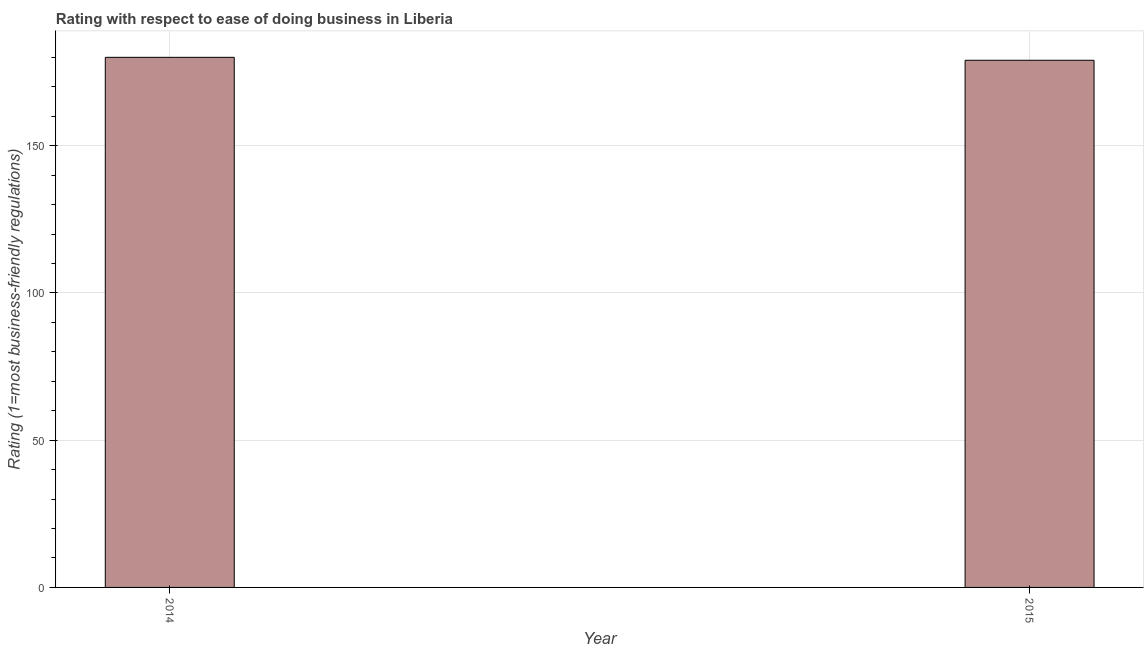What is the title of the graph?
Your answer should be compact. Rating with respect to ease of doing business in Liberia. What is the label or title of the Y-axis?
Ensure brevity in your answer.  Rating (1=most business-friendly regulations). What is the ease of doing business index in 2014?
Your answer should be compact. 180. Across all years, what is the maximum ease of doing business index?
Ensure brevity in your answer.  180. Across all years, what is the minimum ease of doing business index?
Ensure brevity in your answer.  179. In which year was the ease of doing business index minimum?
Your answer should be very brief. 2015. What is the sum of the ease of doing business index?
Offer a terse response. 359. What is the average ease of doing business index per year?
Provide a short and direct response. 179. What is the median ease of doing business index?
Offer a terse response. 179.5. Do a majority of the years between 2015 and 2014 (inclusive) have ease of doing business index greater than 170 ?
Ensure brevity in your answer.  No. What is the ratio of the ease of doing business index in 2014 to that in 2015?
Keep it short and to the point. 1.01. Is the ease of doing business index in 2014 less than that in 2015?
Your response must be concise. No. How many years are there in the graph?
Your response must be concise. 2. Are the values on the major ticks of Y-axis written in scientific E-notation?
Provide a short and direct response. No. What is the Rating (1=most business-friendly regulations) in 2014?
Make the answer very short. 180. What is the Rating (1=most business-friendly regulations) in 2015?
Ensure brevity in your answer.  179. What is the difference between the Rating (1=most business-friendly regulations) in 2014 and 2015?
Your answer should be compact. 1. What is the ratio of the Rating (1=most business-friendly regulations) in 2014 to that in 2015?
Offer a terse response. 1.01. 